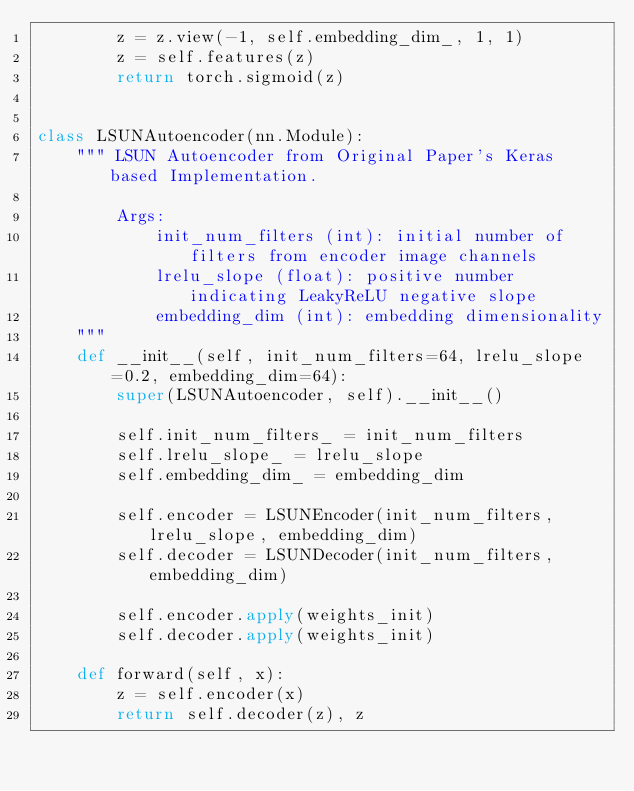Convert code to text. <code><loc_0><loc_0><loc_500><loc_500><_Python_>        z = z.view(-1, self.embedding_dim_, 1, 1)
        z = self.features(z)
        return torch.sigmoid(z)


class LSUNAutoencoder(nn.Module):
    """ LSUN Autoencoder from Original Paper's Keras based Implementation.

        Args:
            init_num_filters (int): initial number of filters from encoder image channels
            lrelu_slope (float): positive number indicating LeakyReLU negative slope
            embedding_dim (int): embedding dimensionality
    """
    def __init__(self, init_num_filters=64, lrelu_slope=0.2, embedding_dim=64):
        super(LSUNAutoencoder, self).__init__()

        self.init_num_filters_ = init_num_filters
        self.lrelu_slope_ = lrelu_slope
        self.embedding_dim_ = embedding_dim

        self.encoder = LSUNEncoder(init_num_filters, lrelu_slope, embedding_dim)
        self.decoder = LSUNDecoder(init_num_filters, embedding_dim)

        self.encoder.apply(weights_init)
        self.decoder.apply(weights_init)

    def forward(self, x):
        z = self.encoder(x)
        return self.decoder(z), z
</code> 